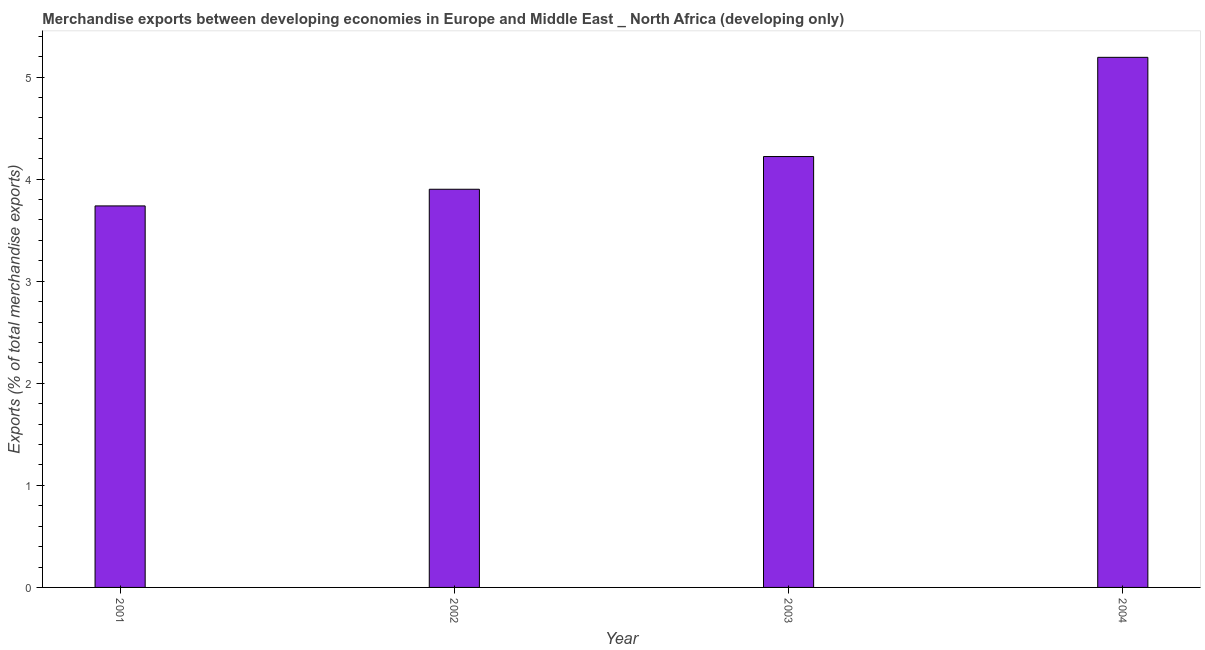Does the graph contain any zero values?
Offer a very short reply. No. What is the title of the graph?
Your response must be concise. Merchandise exports between developing economies in Europe and Middle East _ North Africa (developing only). What is the label or title of the X-axis?
Provide a short and direct response. Year. What is the label or title of the Y-axis?
Your answer should be compact. Exports (% of total merchandise exports). What is the merchandise exports in 2001?
Your answer should be compact. 3.74. Across all years, what is the maximum merchandise exports?
Ensure brevity in your answer.  5.19. Across all years, what is the minimum merchandise exports?
Your answer should be compact. 3.74. In which year was the merchandise exports maximum?
Provide a succinct answer. 2004. In which year was the merchandise exports minimum?
Provide a succinct answer. 2001. What is the sum of the merchandise exports?
Offer a very short reply. 17.05. What is the difference between the merchandise exports in 2002 and 2004?
Ensure brevity in your answer.  -1.29. What is the average merchandise exports per year?
Make the answer very short. 4.26. What is the median merchandise exports?
Provide a succinct answer. 4.06. Do a majority of the years between 2003 and 2001 (inclusive) have merchandise exports greater than 3.4 %?
Offer a very short reply. Yes. What is the ratio of the merchandise exports in 2001 to that in 2002?
Your response must be concise. 0.96. Is the merchandise exports in 2002 less than that in 2003?
Provide a short and direct response. Yes. Is the difference between the merchandise exports in 2001 and 2003 greater than the difference between any two years?
Keep it short and to the point. No. What is the difference between the highest and the second highest merchandise exports?
Ensure brevity in your answer.  0.97. What is the difference between the highest and the lowest merchandise exports?
Make the answer very short. 1.46. How many bars are there?
Provide a succinct answer. 4. Are the values on the major ticks of Y-axis written in scientific E-notation?
Your answer should be very brief. No. What is the Exports (% of total merchandise exports) of 2001?
Ensure brevity in your answer.  3.74. What is the Exports (% of total merchandise exports) in 2002?
Offer a terse response. 3.9. What is the Exports (% of total merchandise exports) of 2003?
Your response must be concise. 4.22. What is the Exports (% of total merchandise exports) in 2004?
Make the answer very short. 5.19. What is the difference between the Exports (% of total merchandise exports) in 2001 and 2002?
Offer a terse response. -0.16. What is the difference between the Exports (% of total merchandise exports) in 2001 and 2003?
Give a very brief answer. -0.48. What is the difference between the Exports (% of total merchandise exports) in 2001 and 2004?
Your response must be concise. -1.46. What is the difference between the Exports (% of total merchandise exports) in 2002 and 2003?
Provide a short and direct response. -0.32. What is the difference between the Exports (% of total merchandise exports) in 2002 and 2004?
Offer a very short reply. -1.29. What is the difference between the Exports (% of total merchandise exports) in 2003 and 2004?
Offer a very short reply. -0.97. What is the ratio of the Exports (% of total merchandise exports) in 2001 to that in 2002?
Your answer should be compact. 0.96. What is the ratio of the Exports (% of total merchandise exports) in 2001 to that in 2003?
Keep it short and to the point. 0.89. What is the ratio of the Exports (% of total merchandise exports) in 2001 to that in 2004?
Provide a succinct answer. 0.72. What is the ratio of the Exports (% of total merchandise exports) in 2002 to that in 2003?
Your answer should be compact. 0.92. What is the ratio of the Exports (% of total merchandise exports) in 2002 to that in 2004?
Make the answer very short. 0.75. What is the ratio of the Exports (% of total merchandise exports) in 2003 to that in 2004?
Provide a short and direct response. 0.81. 